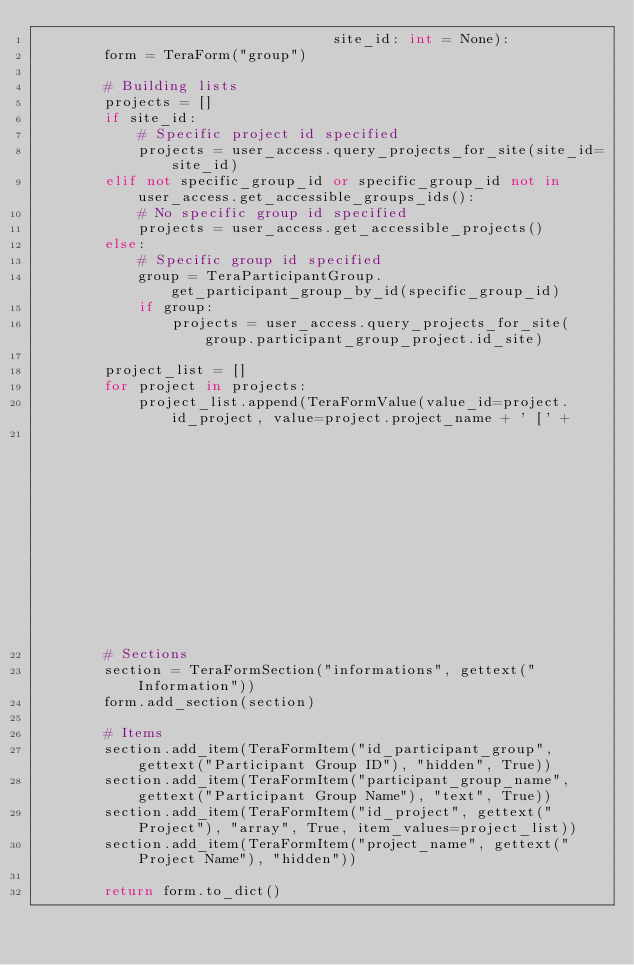Convert code to text. <code><loc_0><loc_0><loc_500><loc_500><_Python_>                                   site_id: int = None):
        form = TeraForm("group")

        # Building lists
        projects = []
        if site_id:
            # Specific project id specified
            projects = user_access.query_projects_for_site(site_id=site_id)
        elif not specific_group_id or specific_group_id not in user_access.get_accessible_groups_ids():
            # No specific group id specified
            projects = user_access.get_accessible_projects()
        else:
            # Specific group id specified
            group = TeraParticipantGroup.get_participant_group_by_id(specific_group_id)
            if group:
                projects = user_access.query_projects_for_site(group.participant_group_project.id_site)

        project_list = []
        for project in projects:
            project_list.append(TeraFormValue(value_id=project.id_project, value=project.project_name + ' [' +
                                                                                project.project_site.site_name + ']'))
        # Sections
        section = TeraFormSection("informations", gettext("Information"))
        form.add_section(section)

        # Items
        section.add_item(TeraFormItem("id_participant_group", gettext("Participant Group ID"), "hidden", True))
        section.add_item(TeraFormItem("participant_group_name", gettext("Participant Group Name"), "text", True))
        section.add_item(TeraFormItem("id_project", gettext("Project"), "array", True, item_values=project_list))
        section.add_item(TeraFormItem("project_name", gettext("Project Name"), "hidden"))

        return form.to_dict()
</code> 